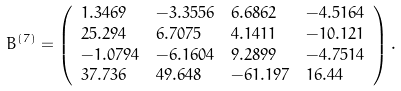Convert formula to latex. <formula><loc_0><loc_0><loc_500><loc_500>B ^ { ( 7 ) } & = \left ( \begin{array} { l l l l } 1 . 3 4 6 9 & - 3 . 3 5 5 6 & 6 . 6 8 6 2 & - 4 . 5 1 6 4 \\ 2 5 . 2 9 4 & 6 . 7 0 7 5 & 4 . 1 4 1 1 & - 1 0 . 1 2 1 \\ - 1 . 0 7 9 4 & - 6 . 1 6 0 4 & 9 . 2 8 9 9 & - 4 . 7 5 1 4 \\ 3 7 . 7 3 6 & 4 9 . 6 4 8 & - 6 1 . 1 9 7 & 1 6 . 4 4 \\ \end{array} \right ) .</formula> 